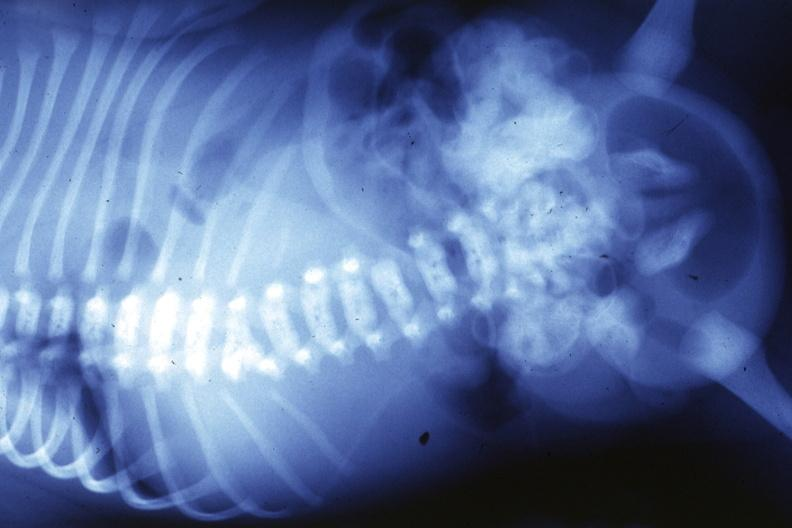what does this image show?
Answer the question using a single word or phrase. X-ray infant 